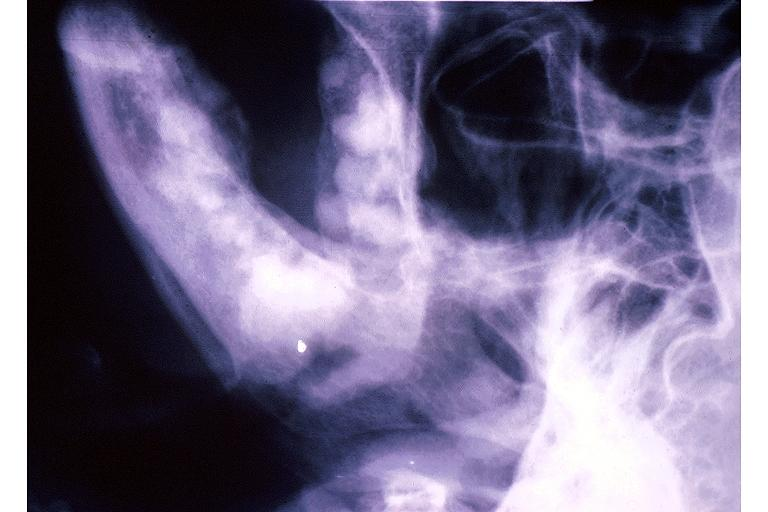does this image show florid cemento-osseous dysplasia?
Answer the question using a single word or phrase. Yes 